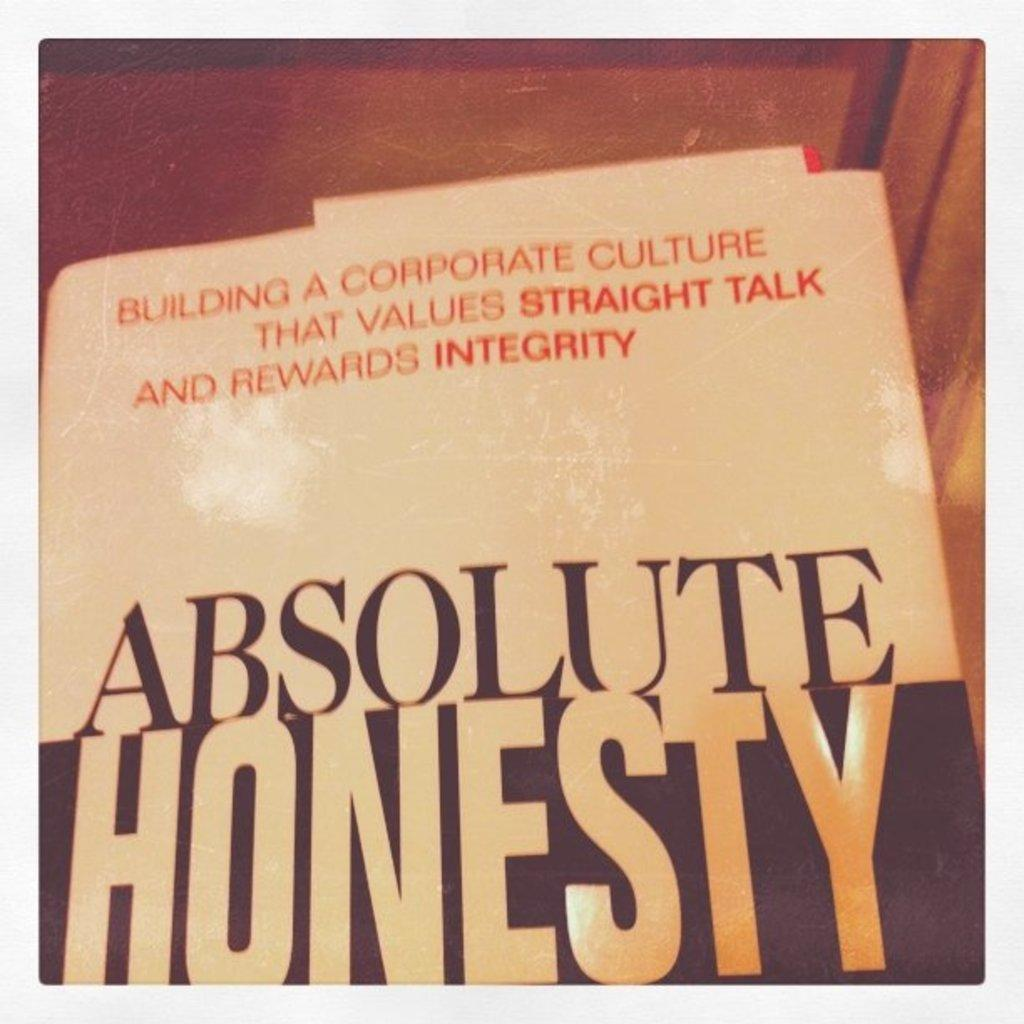<image>
Present a compact description of the photo's key features. A book about corporate cutlure entitled "Absolute Honesty". 